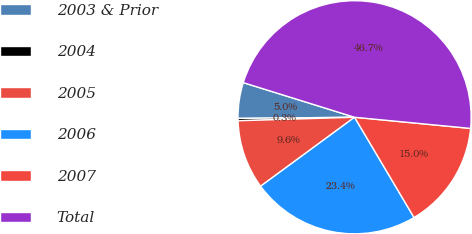<chart> <loc_0><loc_0><loc_500><loc_500><pie_chart><fcel>2003 & Prior<fcel>2004<fcel>2005<fcel>2006<fcel>2007<fcel>Total<nl><fcel>4.96%<fcel>0.32%<fcel>9.6%<fcel>23.44%<fcel>14.95%<fcel>46.72%<nl></chart> 